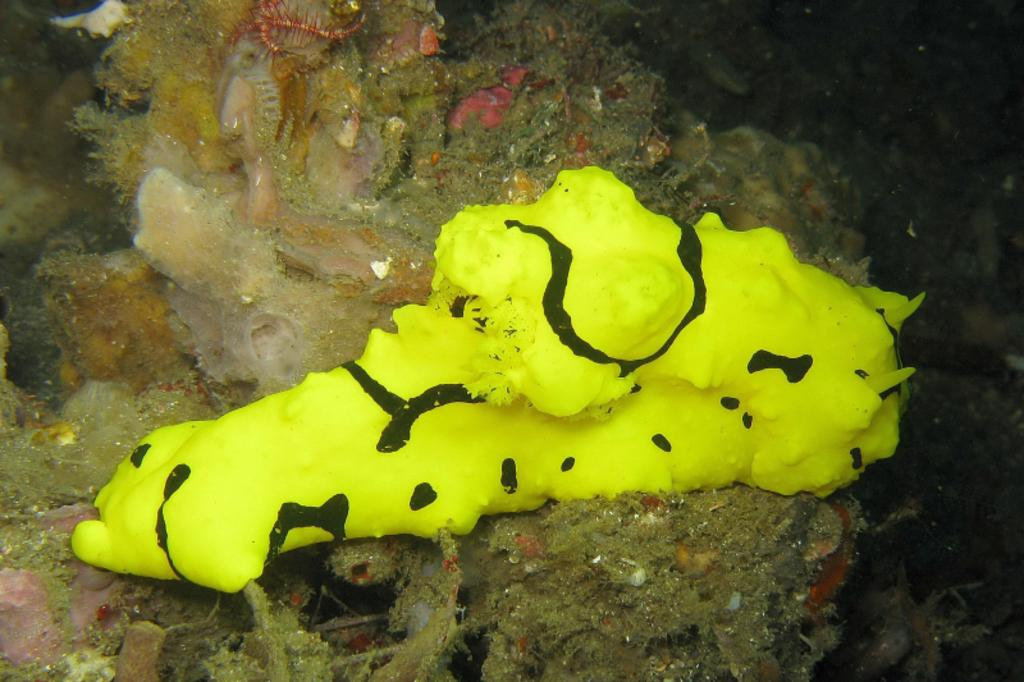What is the main subject in the center of the image? There is an animal in the center of the image. What type of environment is depicted in the image? The image shows a water environment, as there are water plants in the background and at the bottom of the image. What is the taste of the bottle in the image? There is no bottle present in the image, so it is not possible to determine its taste. 